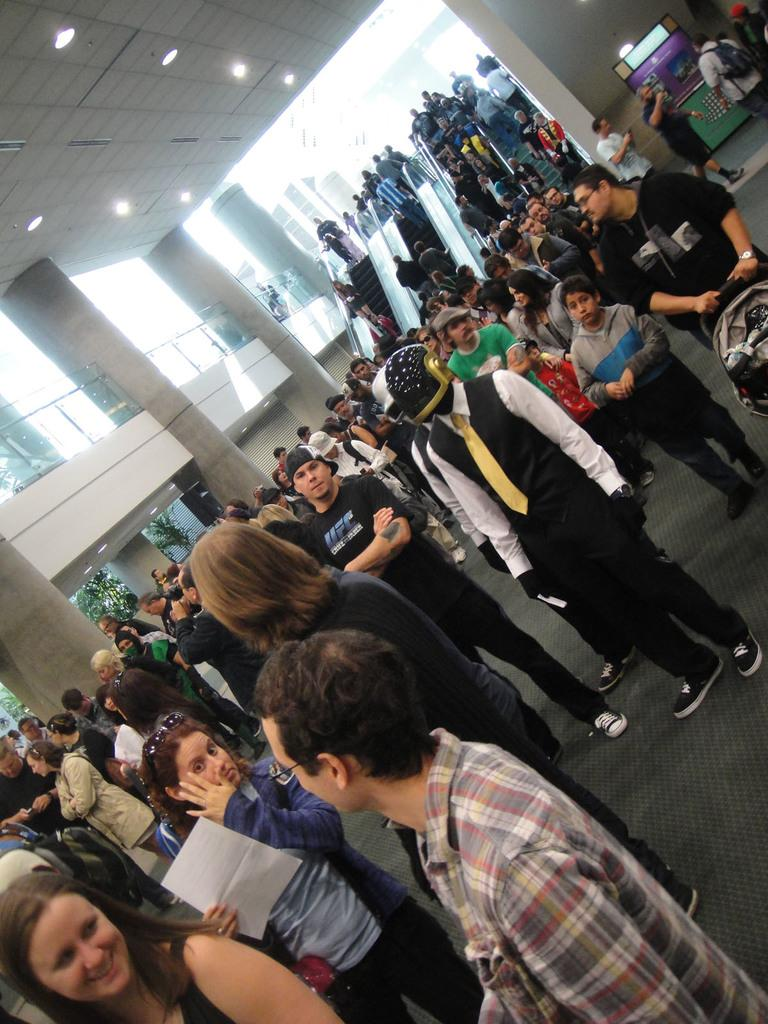How many people are present in the image? There are many people in the image. What can be seen on the left side of the image? There are pillars on the left side of the image. What type of lighting is visible at the top of the image? There are ceiling lights visible at the top of the image. What type of cemetery can be seen in the image? There is no cemetery present in the image; it features many people and architectural elements like pillars and ceiling lights. 